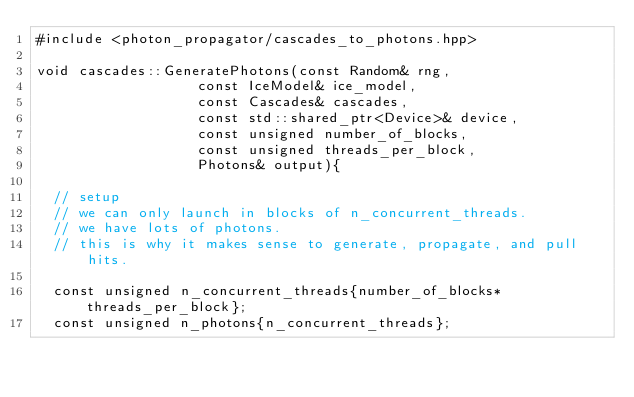<code> <loc_0><loc_0><loc_500><loc_500><_Cuda_>#include <photon_propagator/cascades_to_photons.hpp>

void cascades::GeneratePhotons(const Random& rng,
			       const IceModel& ice_model,
			       const Cascades& cascades,
			       const std::shared_ptr<Device>& device,
			       const unsigned number_of_blocks,
			       const unsigned threads_per_block,
			       Photons& output){
  
  // setup
  // we can only launch in blocks of n_concurrent_threads.
  // we have lots of photons.
  // this is why it makes sense to generate, propagate, and pull hits.    

  const unsigned n_concurrent_threads{number_of_blocks*threads_per_block};
  const unsigned n_photons{n_concurrent_threads};</code> 